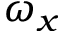Convert formula to latex. <formula><loc_0><loc_0><loc_500><loc_500>\omega _ { x }</formula> 